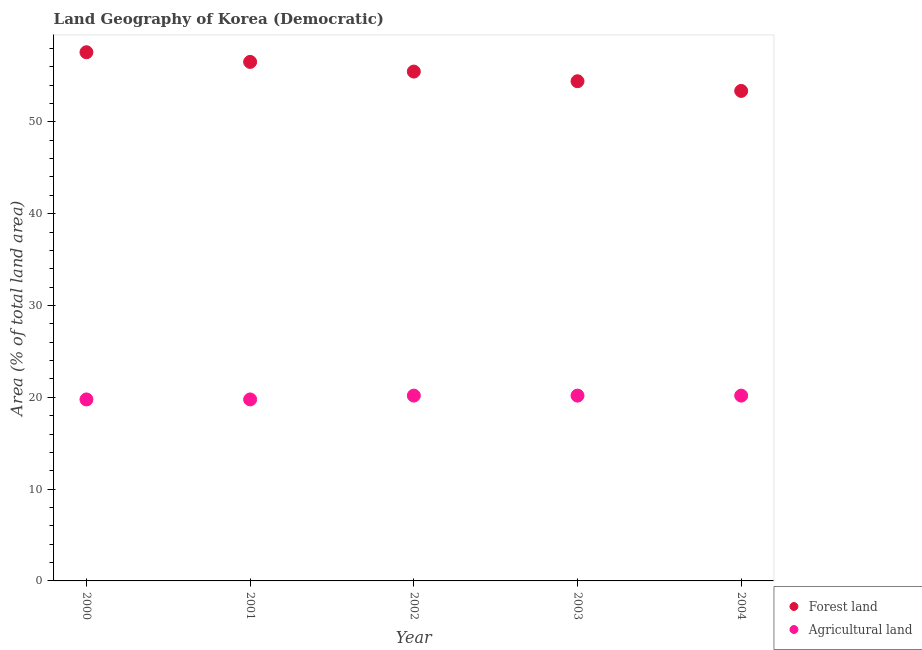How many different coloured dotlines are there?
Your answer should be very brief. 2. Is the number of dotlines equal to the number of legend labels?
Provide a short and direct response. Yes. What is the percentage of land area under forests in 2002?
Make the answer very short. 55.47. Across all years, what is the maximum percentage of land area under agriculture?
Offer a terse response. 20.18. Across all years, what is the minimum percentage of land area under agriculture?
Ensure brevity in your answer.  19.77. In which year was the percentage of land area under agriculture maximum?
Your answer should be very brief. 2002. What is the total percentage of land area under forests in the graph?
Give a very brief answer. 277.36. What is the difference between the percentage of land area under agriculture in 2000 and that in 2003?
Offer a terse response. -0.42. What is the difference between the percentage of land area under forests in 2002 and the percentage of land area under agriculture in 2004?
Your answer should be very brief. 35.29. What is the average percentage of land area under forests per year?
Keep it short and to the point. 55.47. In the year 2004, what is the difference between the percentage of land area under agriculture and percentage of land area under forests?
Your answer should be very brief. -33.18. In how many years, is the percentage of land area under forests greater than 20 %?
Offer a very short reply. 5. What is the ratio of the percentage of land area under forests in 2003 to that in 2004?
Your answer should be very brief. 1.02. What is the difference between the highest and the second highest percentage of land area under forests?
Offer a very short reply. 1.05. What is the difference between the highest and the lowest percentage of land area under agriculture?
Offer a very short reply. 0.42. Does the percentage of land area under forests monotonically increase over the years?
Give a very brief answer. No. Is the percentage of land area under agriculture strictly less than the percentage of land area under forests over the years?
Offer a terse response. Yes. What is the title of the graph?
Your response must be concise. Land Geography of Korea (Democratic). Does "Age 65(male)" appear as one of the legend labels in the graph?
Offer a very short reply. No. What is the label or title of the Y-axis?
Ensure brevity in your answer.  Area (% of total land area). What is the Area (% of total land area) in Forest land in 2000?
Offer a very short reply. 57.58. What is the Area (% of total land area) of Agricultural land in 2000?
Your answer should be very brief. 19.77. What is the Area (% of total land area) of Forest land in 2001?
Ensure brevity in your answer.  56.53. What is the Area (% of total land area) of Agricultural land in 2001?
Your response must be concise. 19.77. What is the Area (% of total land area) in Forest land in 2002?
Ensure brevity in your answer.  55.47. What is the Area (% of total land area) of Agricultural land in 2002?
Make the answer very short. 20.18. What is the Area (% of total land area) in Forest land in 2003?
Offer a terse response. 54.42. What is the Area (% of total land area) in Agricultural land in 2003?
Offer a very short reply. 20.18. What is the Area (% of total land area) of Forest land in 2004?
Provide a succinct answer. 53.37. What is the Area (% of total land area) of Agricultural land in 2004?
Offer a very short reply. 20.18. Across all years, what is the maximum Area (% of total land area) of Forest land?
Offer a very short reply. 57.58. Across all years, what is the maximum Area (% of total land area) of Agricultural land?
Offer a very short reply. 20.18. Across all years, what is the minimum Area (% of total land area) in Forest land?
Provide a short and direct response. 53.37. Across all years, what is the minimum Area (% of total land area) of Agricultural land?
Provide a short and direct response. 19.77. What is the total Area (% of total land area) in Forest land in the graph?
Offer a very short reply. 277.36. What is the total Area (% of total land area) of Agricultural land in the graph?
Ensure brevity in your answer.  100.07. What is the difference between the Area (% of total land area) in Forest land in 2000 and that in 2001?
Make the answer very short. 1.05. What is the difference between the Area (% of total land area) in Agricultural land in 2000 and that in 2001?
Ensure brevity in your answer.  0. What is the difference between the Area (% of total land area) in Forest land in 2000 and that in 2002?
Ensure brevity in your answer.  2.11. What is the difference between the Area (% of total land area) of Agricultural land in 2000 and that in 2002?
Your answer should be compact. -0.42. What is the difference between the Area (% of total land area) of Forest land in 2000 and that in 2003?
Offer a very short reply. 3.16. What is the difference between the Area (% of total land area) in Agricultural land in 2000 and that in 2003?
Your answer should be very brief. -0.42. What is the difference between the Area (% of total land area) of Forest land in 2000 and that in 2004?
Keep it short and to the point. 4.21. What is the difference between the Area (% of total land area) of Agricultural land in 2000 and that in 2004?
Keep it short and to the point. -0.42. What is the difference between the Area (% of total land area) of Forest land in 2001 and that in 2002?
Your answer should be compact. 1.05. What is the difference between the Area (% of total land area) of Agricultural land in 2001 and that in 2002?
Provide a succinct answer. -0.42. What is the difference between the Area (% of total land area) in Forest land in 2001 and that in 2003?
Your answer should be very brief. 2.11. What is the difference between the Area (% of total land area) of Agricultural land in 2001 and that in 2003?
Keep it short and to the point. -0.42. What is the difference between the Area (% of total land area) in Forest land in 2001 and that in 2004?
Make the answer very short. 3.16. What is the difference between the Area (% of total land area) in Agricultural land in 2001 and that in 2004?
Give a very brief answer. -0.42. What is the difference between the Area (% of total land area) of Forest land in 2002 and that in 2003?
Your answer should be compact. 1.05. What is the difference between the Area (% of total land area) of Agricultural land in 2002 and that in 2003?
Ensure brevity in your answer.  0. What is the difference between the Area (% of total land area) of Forest land in 2002 and that in 2004?
Offer a terse response. 2.11. What is the difference between the Area (% of total land area) of Agricultural land in 2002 and that in 2004?
Offer a very short reply. 0. What is the difference between the Area (% of total land area) of Forest land in 2003 and that in 2004?
Make the answer very short. 1.05. What is the difference between the Area (% of total land area) of Forest land in 2000 and the Area (% of total land area) of Agricultural land in 2001?
Offer a terse response. 37.81. What is the difference between the Area (% of total land area) of Forest land in 2000 and the Area (% of total land area) of Agricultural land in 2002?
Offer a very short reply. 37.4. What is the difference between the Area (% of total land area) in Forest land in 2000 and the Area (% of total land area) in Agricultural land in 2003?
Offer a terse response. 37.4. What is the difference between the Area (% of total land area) in Forest land in 2000 and the Area (% of total land area) in Agricultural land in 2004?
Your answer should be compact. 37.4. What is the difference between the Area (% of total land area) of Forest land in 2001 and the Area (% of total land area) of Agricultural land in 2002?
Your answer should be compact. 36.34. What is the difference between the Area (% of total land area) in Forest land in 2001 and the Area (% of total land area) in Agricultural land in 2003?
Give a very brief answer. 36.34. What is the difference between the Area (% of total land area) in Forest land in 2001 and the Area (% of total land area) in Agricultural land in 2004?
Offer a very short reply. 36.34. What is the difference between the Area (% of total land area) in Forest land in 2002 and the Area (% of total land area) in Agricultural land in 2003?
Your answer should be compact. 35.29. What is the difference between the Area (% of total land area) in Forest land in 2002 and the Area (% of total land area) in Agricultural land in 2004?
Provide a succinct answer. 35.29. What is the difference between the Area (% of total land area) of Forest land in 2003 and the Area (% of total land area) of Agricultural land in 2004?
Give a very brief answer. 34.24. What is the average Area (% of total land area) in Forest land per year?
Make the answer very short. 55.47. What is the average Area (% of total land area) of Agricultural land per year?
Your response must be concise. 20.01. In the year 2000, what is the difference between the Area (% of total land area) in Forest land and Area (% of total land area) in Agricultural land?
Keep it short and to the point. 37.81. In the year 2001, what is the difference between the Area (% of total land area) of Forest land and Area (% of total land area) of Agricultural land?
Keep it short and to the point. 36.76. In the year 2002, what is the difference between the Area (% of total land area) of Forest land and Area (% of total land area) of Agricultural land?
Provide a succinct answer. 35.29. In the year 2003, what is the difference between the Area (% of total land area) of Forest land and Area (% of total land area) of Agricultural land?
Offer a terse response. 34.24. In the year 2004, what is the difference between the Area (% of total land area) of Forest land and Area (% of total land area) of Agricultural land?
Give a very brief answer. 33.19. What is the ratio of the Area (% of total land area) in Forest land in 2000 to that in 2001?
Offer a terse response. 1.02. What is the ratio of the Area (% of total land area) in Forest land in 2000 to that in 2002?
Ensure brevity in your answer.  1.04. What is the ratio of the Area (% of total land area) in Agricultural land in 2000 to that in 2002?
Your answer should be very brief. 0.98. What is the ratio of the Area (% of total land area) in Forest land in 2000 to that in 2003?
Your response must be concise. 1.06. What is the ratio of the Area (% of total land area) of Agricultural land in 2000 to that in 2003?
Ensure brevity in your answer.  0.98. What is the ratio of the Area (% of total land area) of Forest land in 2000 to that in 2004?
Your answer should be very brief. 1.08. What is the ratio of the Area (% of total land area) of Agricultural land in 2000 to that in 2004?
Your answer should be compact. 0.98. What is the ratio of the Area (% of total land area) of Forest land in 2001 to that in 2002?
Offer a terse response. 1.02. What is the ratio of the Area (% of total land area) in Agricultural land in 2001 to that in 2002?
Your answer should be very brief. 0.98. What is the ratio of the Area (% of total land area) in Forest land in 2001 to that in 2003?
Give a very brief answer. 1.04. What is the ratio of the Area (% of total land area) in Agricultural land in 2001 to that in 2003?
Ensure brevity in your answer.  0.98. What is the ratio of the Area (% of total land area) in Forest land in 2001 to that in 2004?
Offer a very short reply. 1.06. What is the ratio of the Area (% of total land area) in Agricultural land in 2001 to that in 2004?
Ensure brevity in your answer.  0.98. What is the ratio of the Area (% of total land area) of Forest land in 2002 to that in 2003?
Make the answer very short. 1.02. What is the ratio of the Area (% of total land area) in Agricultural land in 2002 to that in 2003?
Your response must be concise. 1. What is the ratio of the Area (% of total land area) of Forest land in 2002 to that in 2004?
Provide a succinct answer. 1.04. What is the ratio of the Area (% of total land area) in Agricultural land in 2002 to that in 2004?
Give a very brief answer. 1. What is the ratio of the Area (% of total land area) of Forest land in 2003 to that in 2004?
Ensure brevity in your answer.  1.02. What is the ratio of the Area (% of total land area) in Agricultural land in 2003 to that in 2004?
Offer a terse response. 1. What is the difference between the highest and the second highest Area (% of total land area) of Forest land?
Give a very brief answer. 1.05. What is the difference between the highest and the second highest Area (% of total land area) of Agricultural land?
Your answer should be very brief. 0. What is the difference between the highest and the lowest Area (% of total land area) of Forest land?
Your response must be concise. 4.21. What is the difference between the highest and the lowest Area (% of total land area) of Agricultural land?
Provide a succinct answer. 0.42. 